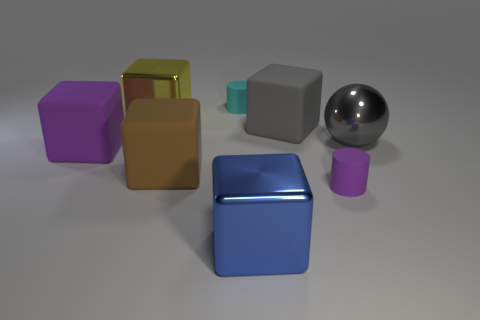Subtract all blue blocks. How many blocks are left? 4 Subtract all yellow shiny cubes. How many cubes are left? 4 Subtract all green blocks. Subtract all gray cylinders. How many blocks are left? 5 Add 1 big yellow objects. How many objects exist? 9 Subtract all blocks. How many objects are left? 3 Add 1 gray spheres. How many gray spheres are left? 2 Add 2 rubber cubes. How many rubber cubes exist? 5 Subtract 0 blue cylinders. How many objects are left? 8 Subtract all large purple rubber blocks. Subtract all cyan cylinders. How many objects are left? 6 